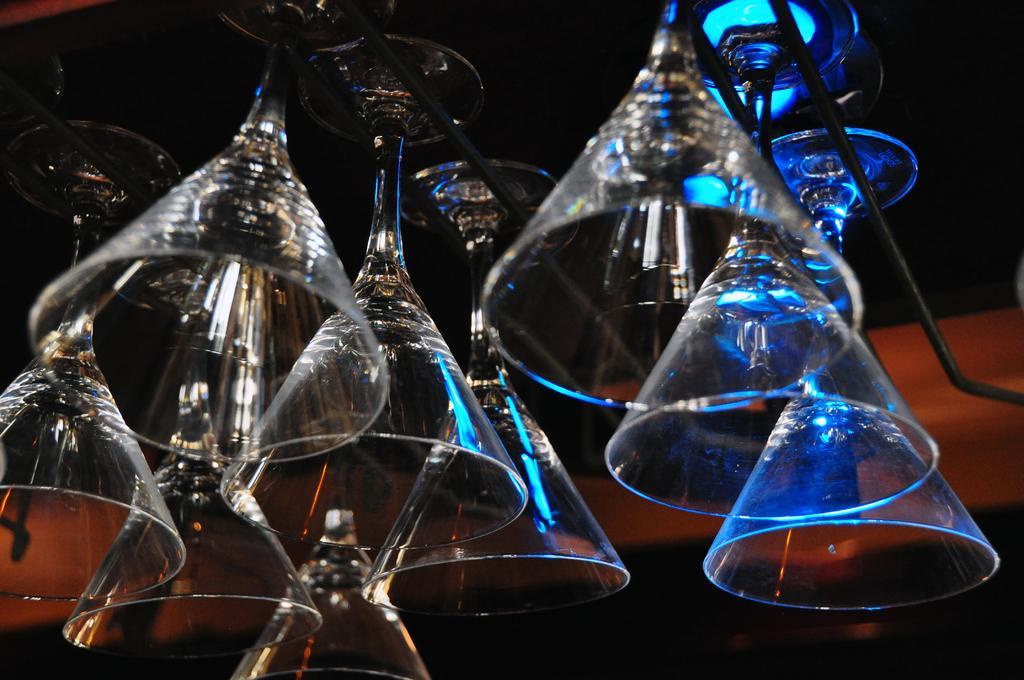Describe this image in one or two sentences. In this image we can see glasses and rods. In the background it is blur. 